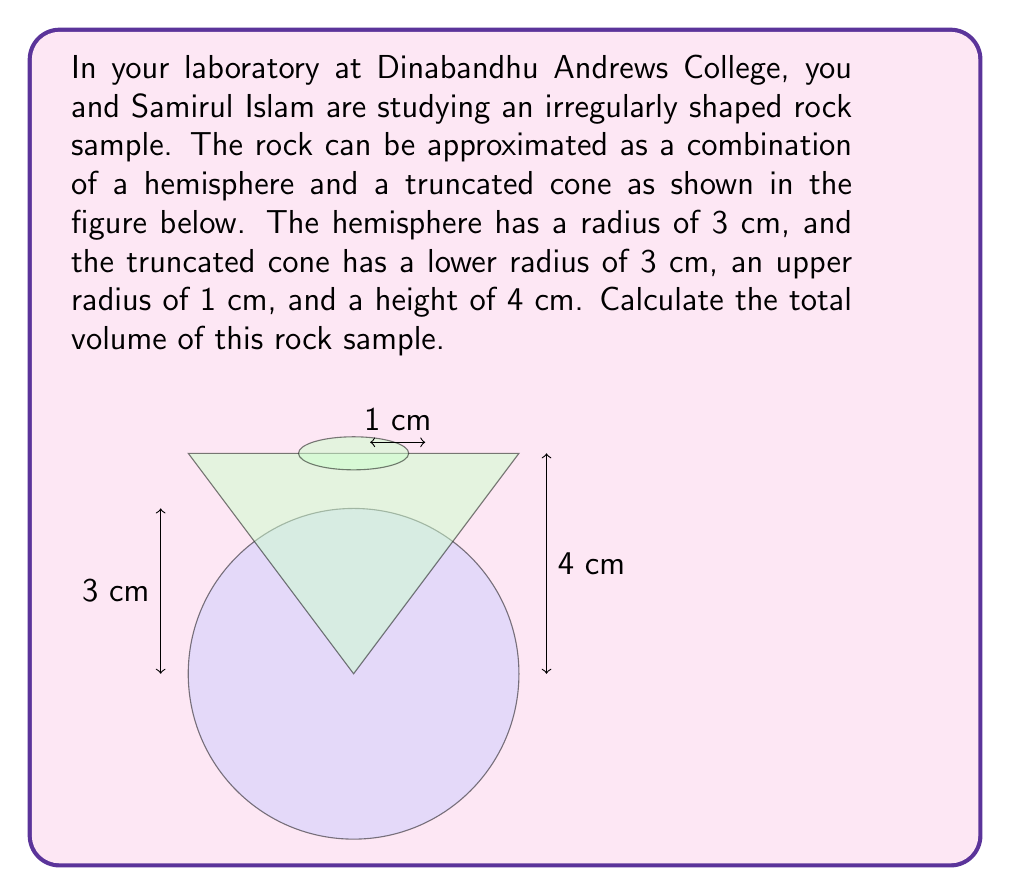What is the answer to this math problem? To calculate the total volume of the rock sample, we need to sum the volumes of the hemisphere and the truncated cone.

1. Volume of the hemisphere:
   The formula for the volume of a hemisphere is:
   $$V_h = \frac{2}{3}\pi r^3$$
   Where $r$ is the radius.
   $$V_h = \frac{2}{3}\pi (3\text{ cm})^3 = 18\pi \text{ cm}^3$$

2. Volume of the truncated cone:
   The formula for the volume of a truncated cone is:
   $$V_c = \frac{1}{3}\pi h(R^2 + r^2 + Rr)$$
   Where $h$ is the height, $R$ is the radius of the base, and $r$ is the radius of the top.
   $$V_c = \frac{1}{3}\pi (4\text{ cm})((3\text{ cm})^2 + (1\text{ cm})^2 + (3\text{ cm})(1\text{ cm}))$$
   $$V_c = \frac{4\pi}{3}(9 + 1 + 3) \text{ cm}^3 = \frac{52\pi}{3} \text{ cm}^3$$

3. Total volume:
   $$V_{total} = V_h + V_c = 18\pi \text{ cm}^3 + \frac{52\pi}{3} \text{ cm}^3 = \frac{54\pi + 52\pi}{3} \text{ cm}^3 = \frac{106\pi}{3} \text{ cm}^3$$
Answer: $\frac{106\pi}{3} \text{ cm}^3$ 